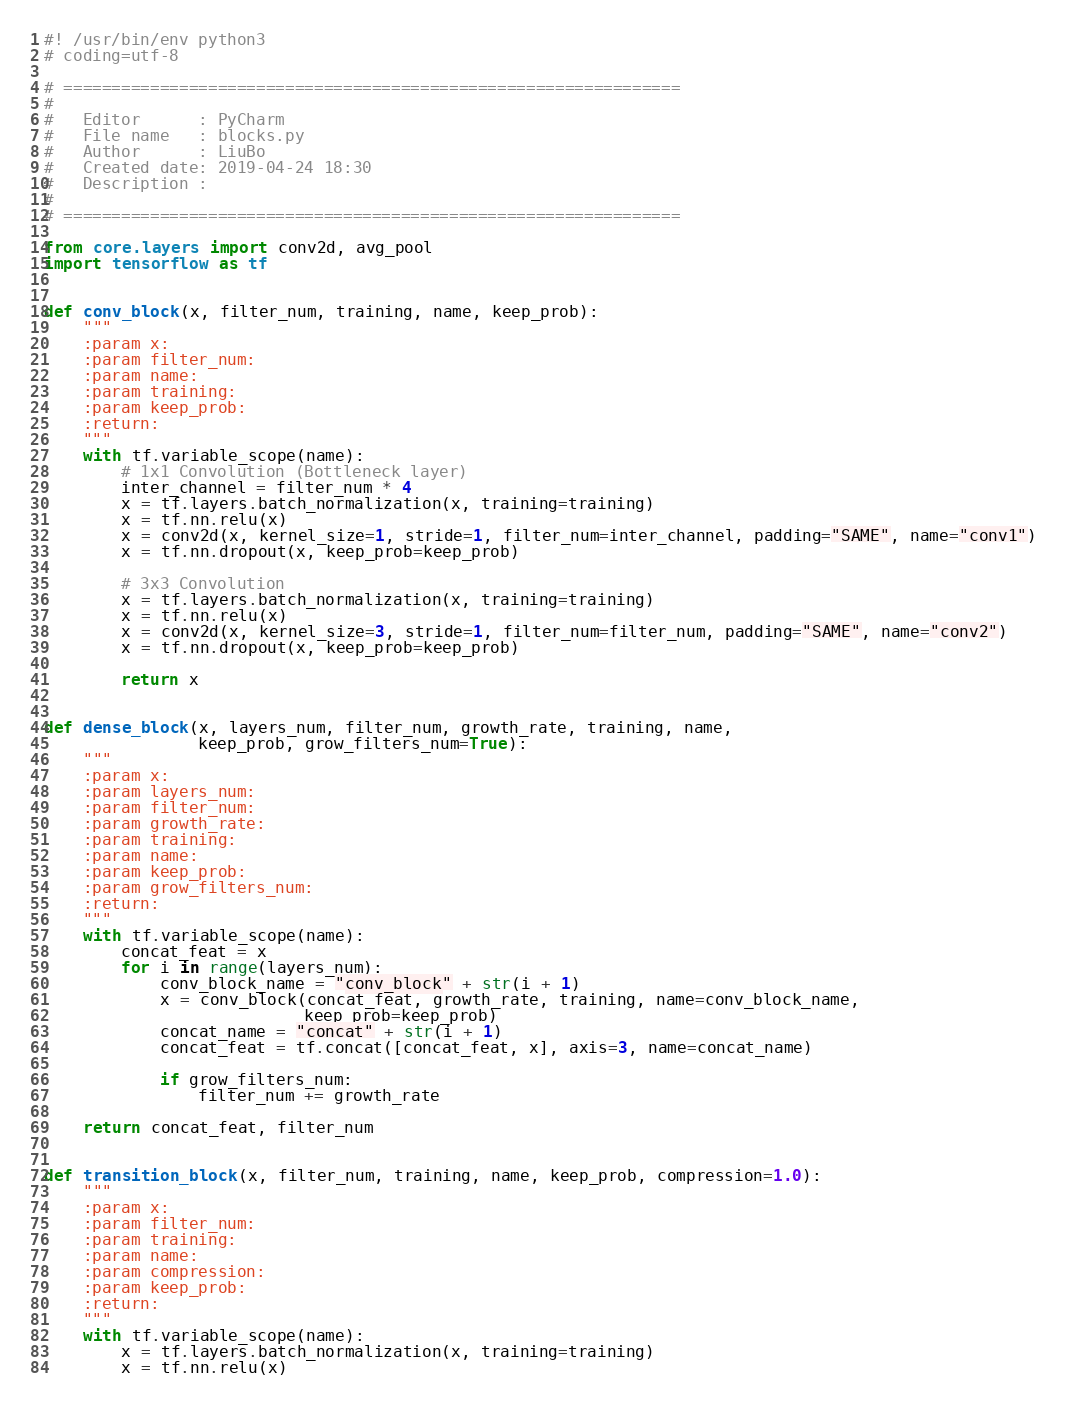Convert code to text. <code><loc_0><loc_0><loc_500><loc_500><_Python_>#! /usr/bin/env python3
# coding=utf-8

# ================================================================
#
#   Editor      : PyCharm
#   File name   : blocks.py
#   Author      : LiuBo
#   Created date: 2019-04-24 18:30
#   Description :
#
# ================================================================

from core.layers import conv2d, avg_pool
import tensorflow as tf


def conv_block(x, filter_num, training, name, keep_prob):
    """
    :param x:
    :param filter_num:
    :param name:
    :param training:
    :param keep_prob:
    :return:
    """
    with tf.variable_scope(name):
        # 1x1 Convolution (Bottleneck layer)
        inter_channel = filter_num * 4
        x = tf.layers.batch_normalization(x, training=training)
        x = tf.nn.relu(x)
        x = conv2d(x, kernel_size=1, stride=1, filter_num=inter_channel, padding="SAME", name="conv1")
        x = tf.nn.dropout(x, keep_prob=keep_prob)

        # 3x3 Convolution
        x = tf.layers.batch_normalization(x, training=training)
        x = tf.nn.relu(x)
        x = conv2d(x, kernel_size=3, stride=1, filter_num=filter_num, padding="SAME", name="conv2")
        x = tf.nn.dropout(x, keep_prob=keep_prob)

        return x


def dense_block(x, layers_num, filter_num, growth_rate, training, name,
                keep_prob, grow_filters_num=True):
    """
    :param x:
    :param layers_num:
    :param filter_num:
    :param growth_rate:
    :param training:
    :param name:
    :param keep_prob:
    :param grow_filters_num:
    :return:
    """
    with tf.variable_scope(name):
        concat_feat = x
        for i in range(layers_num):
            conv_block_name = "conv_block" + str(i + 1)
            x = conv_block(concat_feat, growth_rate, training, name=conv_block_name,
                           keep_prob=keep_prob)
            concat_name = "concat" + str(i + 1)
            concat_feat = tf.concat([concat_feat, x], axis=3, name=concat_name)

            if grow_filters_num:
                filter_num += growth_rate

    return concat_feat, filter_num


def transition_block(x, filter_num, training, name, keep_prob, compression=1.0):
    """
    :param x:
    :param filter_num:
    :param training:
    :param name:
    :param compression:
    :param keep_prob:
    :return:
    """
    with tf.variable_scope(name):
        x = tf.layers.batch_normalization(x, training=training)
        x = tf.nn.relu(x)</code> 